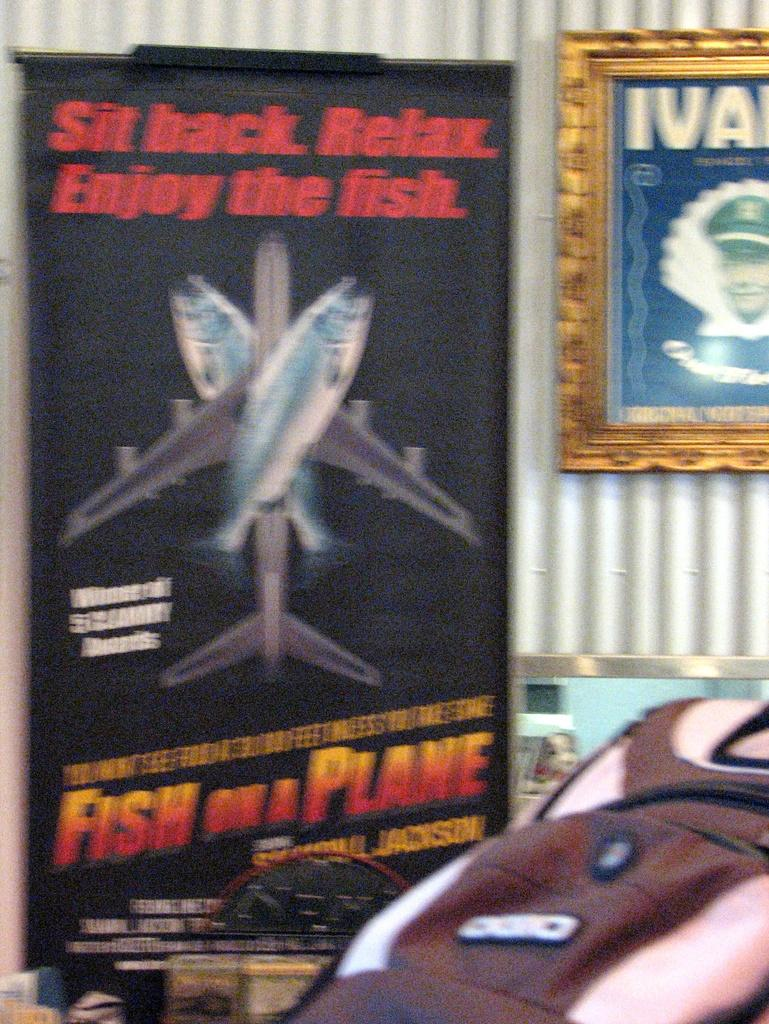<image>
Offer a succinct explanation of the picture presented. A Fish on a plane movie poster hanging next to a picture. 